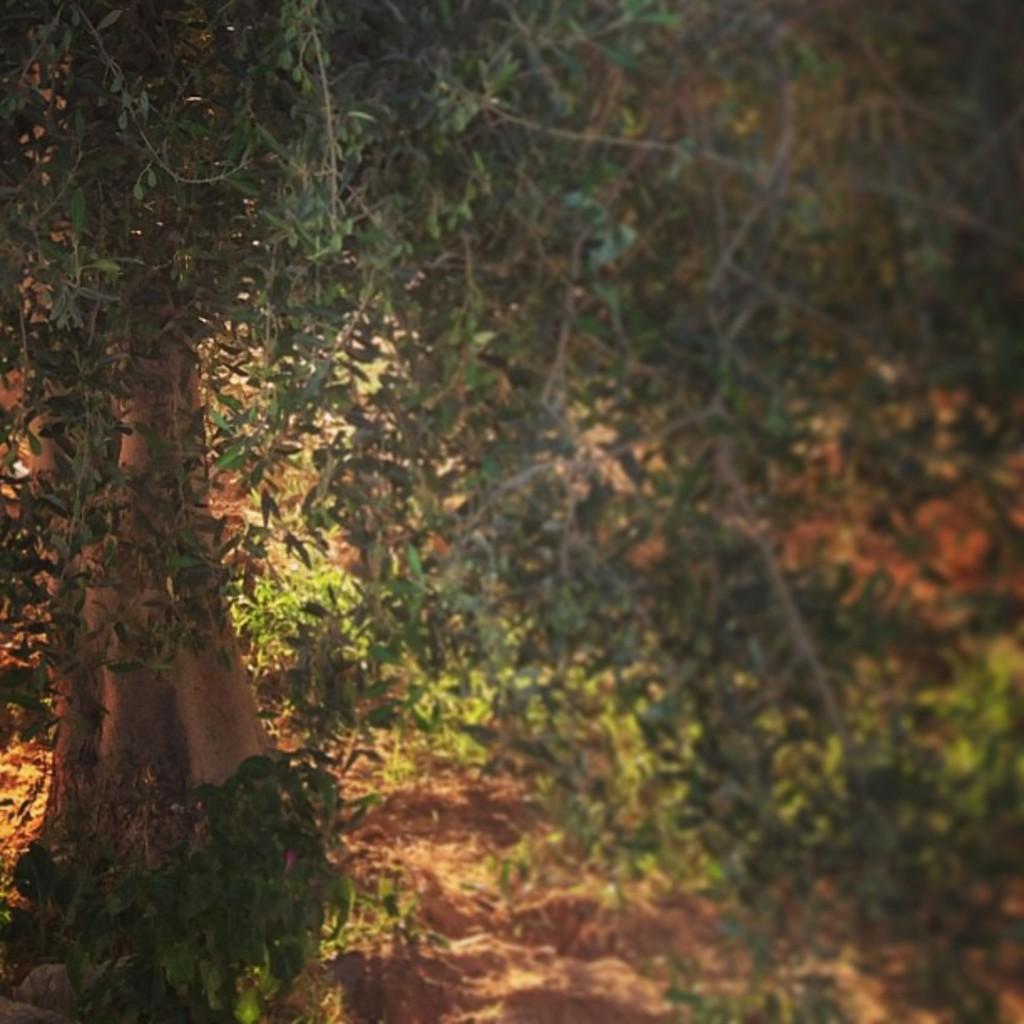How would you summarize this image in a sentence or two? In this image we can see there are trees and plants on the ground. 